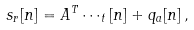Convert formula to latex. <formula><loc_0><loc_0><loc_500><loc_500>s _ { r } [ n ] = A ^ { T } \cdots _ { t } [ n ] + q _ { a } [ n ] \, ,</formula> 